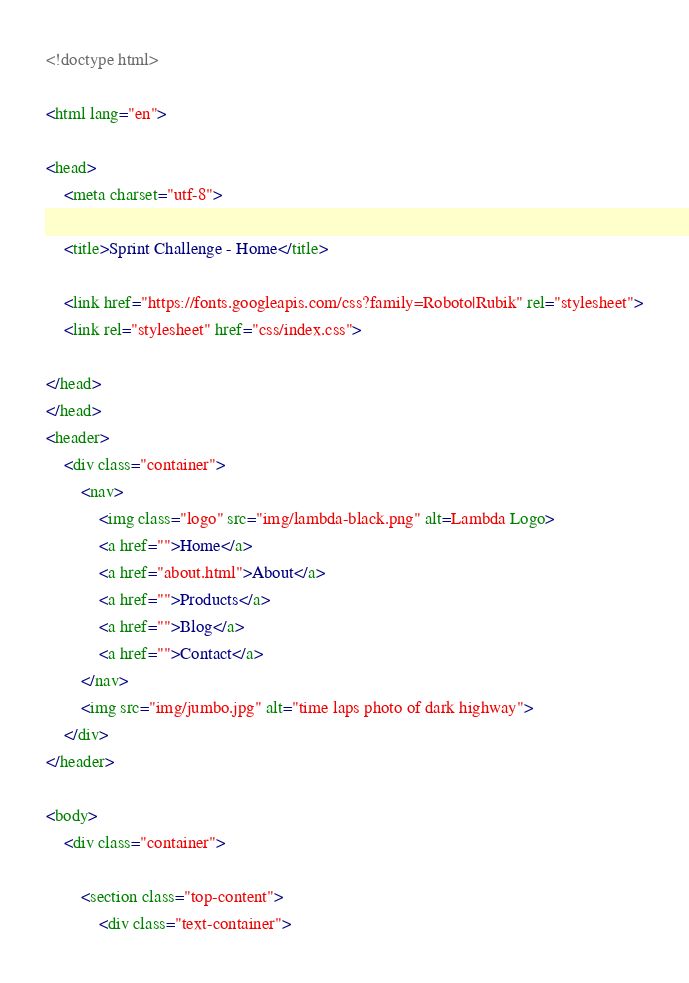Convert code to text. <code><loc_0><loc_0><loc_500><loc_500><_HTML_><!doctype html>

<html lang="en">

<head>
    <meta charset="utf-8">

    <title>Sprint Challenge - Home</title>

    <link href="https://fonts.googleapis.com/css?family=Roboto|Rubik" rel="stylesheet">
    <link rel="stylesheet" href="css/index.css">

</head>
</head>
<header>
    <div class="container">
        <nav>
            <img class="logo" src="img/lambda-black.png" alt=Lambda Logo>
            <a href="">Home</a>
            <a href="about.html">About</a>
            <a href="">Products</a>
            <a href="">Blog</a>
            <a href="">Contact</a>
        </nav>
        <img src="img/jumbo.jpg" alt="time laps photo of dark highway">
    </div>
</header>

<body>
    <div class="container">

        <section class="top-content">
            <div class="text-container"></code> 